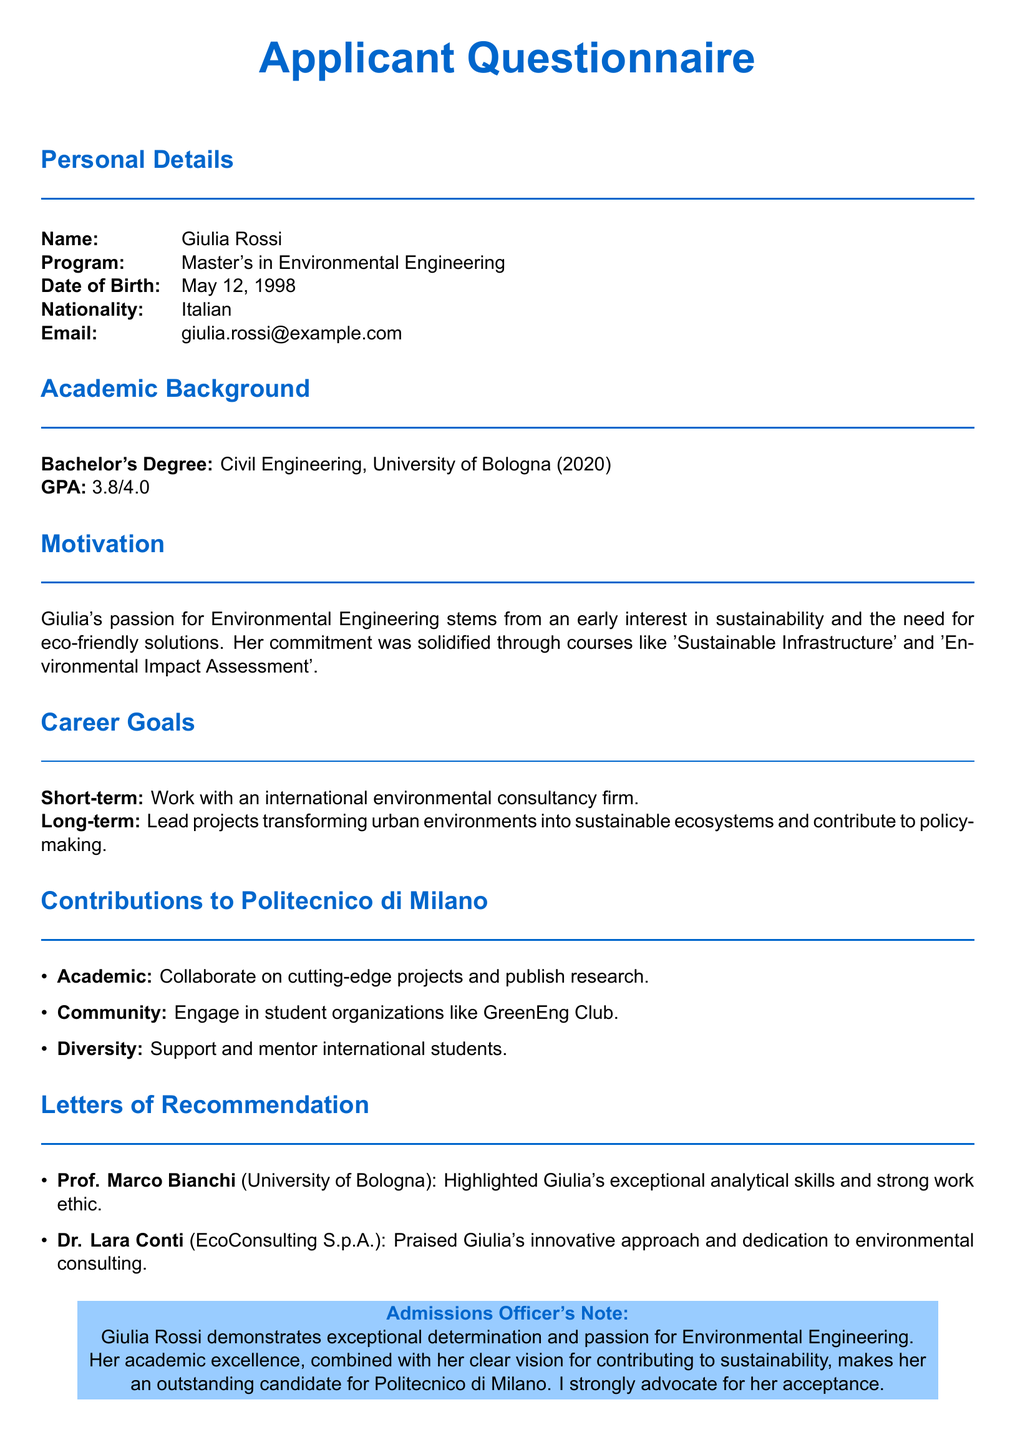What is the applicant's name? The applicant's name is presented in the personal details section of the document.
Answer: Giulia Rossi What is the GPA of the applicant? The GPA is mentioned under the academic background section.
Answer: 3.8/4.0 What is Giulia's planned short-term career goal? The short-term career goal is specified in the career goals section.
Answer: Work with an international environmental consultancy firm What program is Giulia applying for? The program is listed in the personal details section of the document.
Answer: Master's in Environmental Engineering Which club does Giulia plan to engage with at Politecnico di Milano? Engagement in the club is mentioned as part of her contributions to the community section.
Answer: GreenEng Club What year did Giulia obtain her Bachelor's Degree? The year is indicated in the academic background section.
Answer: 2020 Who recommended Giulia from EcoConsulting S.p.A.? The recommender is noted in the letters of recommendation section of the document.
Answer: Dr. Lara Conti What subject solidified Giulia's commitment to Environmental Engineering? The subject is mentioned in the motivation section of the document.
Answer: Environmental Impact Assessment What degree did Giulia complete at the University of Bologna? The degree is outlined in the academic background section.
Answer: Civil Engineering 